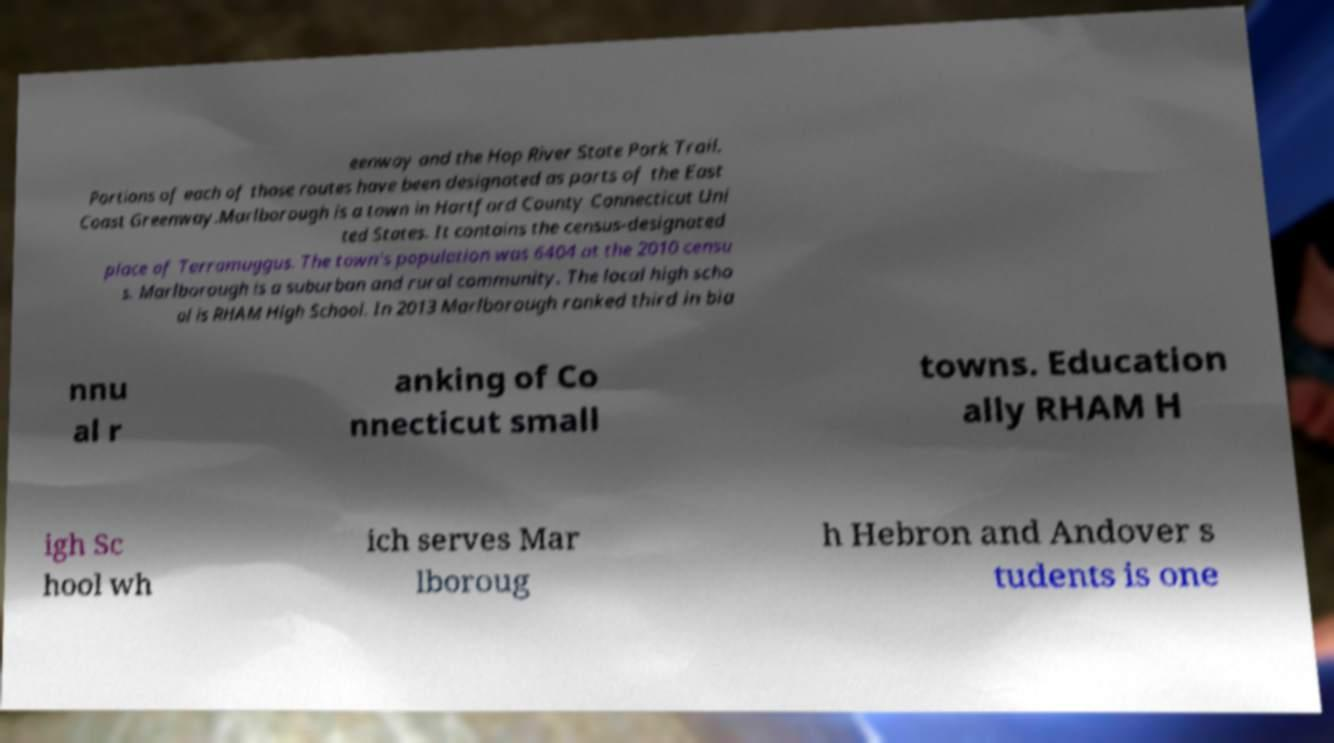What messages or text are displayed in this image? I need them in a readable, typed format. eenway and the Hop River State Park Trail. Portions of each of those routes have been designated as parts of the East Coast Greenway.Marlborough is a town in Hartford County Connecticut Uni ted States. It contains the census-designated place of Terramuggus. The town's population was 6404 at the 2010 censu s. Marlborough is a suburban and rural community. The local high scho ol is RHAM High School. In 2013 Marlborough ranked third in bia nnu al r anking of Co nnecticut small towns. Education ally RHAM H igh Sc hool wh ich serves Mar lboroug h Hebron and Andover s tudents is one 